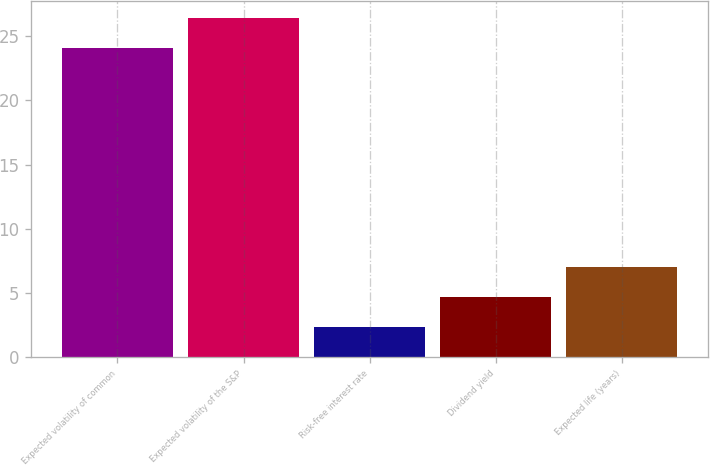Convert chart. <chart><loc_0><loc_0><loc_500><loc_500><bar_chart><fcel>Expected volatility of common<fcel>Expected volatility of the S&P<fcel>Risk-free interest rate<fcel>Dividend yield<fcel>Expected life (years)<nl><fcel>24.1<fcel>26.42<fcel>2.4<fcel>4.72<fcel>7.04<nl></chart> 